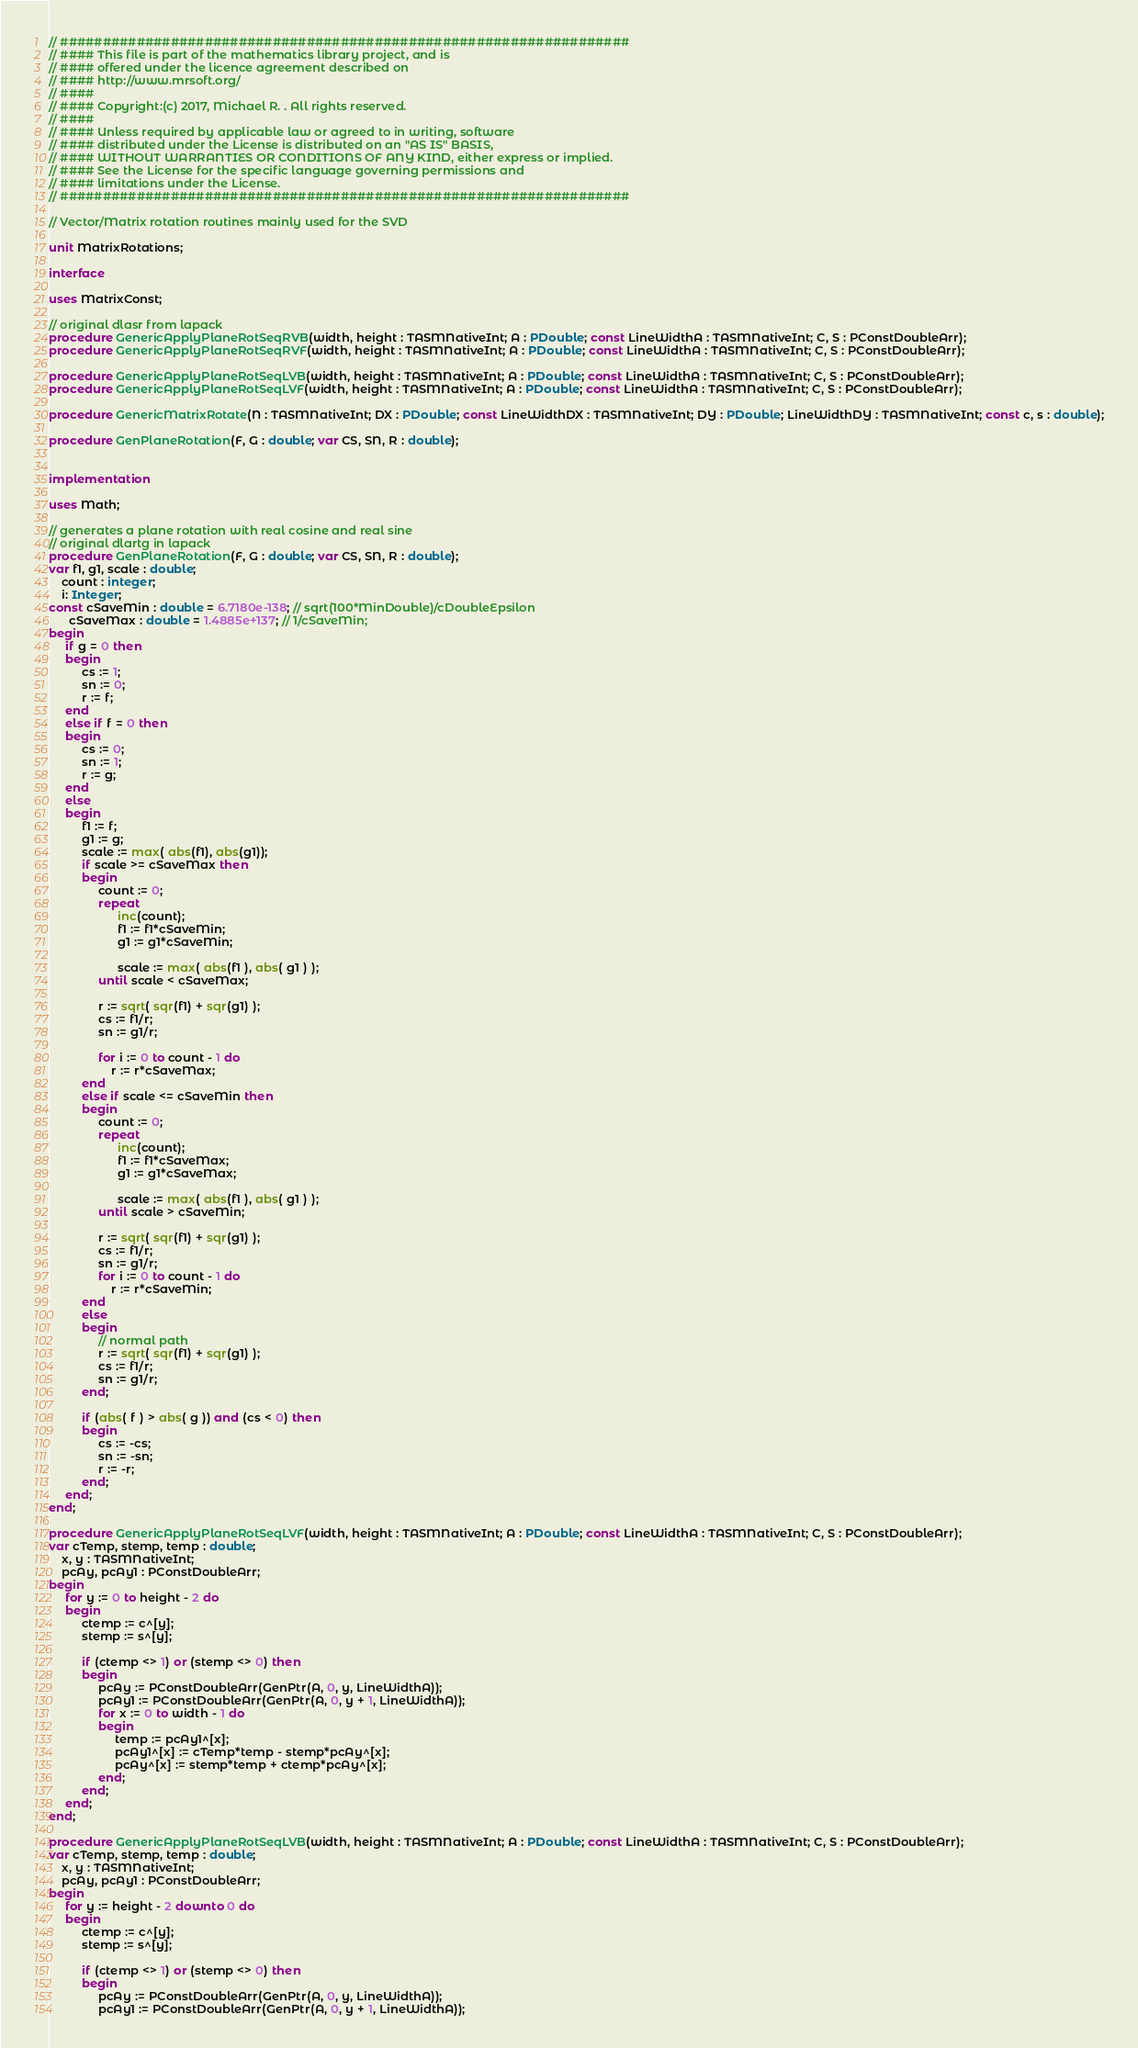<code> <loc_0><loc_0><loc_500><loc_500><_Pascal_>// ###################################################################
// #### This file is part of the mathematics library project, and is
// #### offered under the licence agreement described on
// #### http://www.mrsoft.org/
// ####
// #### Copyright:(c) 2017, Michael R. . All rights reserved.
// ####
// #### Unless required by applicable law or agreed to in writing, software
// #### distributed under the License is distributed on an "AS IS" BASIS,
// #### WITHOUT WARRANTIES OR CONDITIONS OF ANY KIND, either express or implied.
// #### See the License for the specific language governing permissions and
// #### limitations under the License.
// ###################################################################

// Vector/Matrix rotation routines mainly used for the SVD

unit MatrixRotations;

interface

uses MatrixConst;

// original dlasr from lapack
procedure GenericApplyPlaneRotSeqRVB(width, height : TASMNativeInt; A : PDouble; const LineWidthA : TASMNativeInt; C, S : PConstDoubleArr);
procedure GenericApplyPlaneRotSeqRVF(width, height : TASMNativeInt; A : PDouble; const LineWidthA : TASMNativeInt; C, S : PConstDoubleArr);

procedure GenericApplyPlaneRotSeqLVB(width, height : TASMNativeInt; A : PDouble; const LineWidthA : TASMNativeInt; C, S : PConstDoubleArr);
procedure GenericApplyPlaneRotSeqLVF(width, height : TASMNativeInt; A : PDouble; const LineWidthA : TASMNativeInt; C, S : PConstDoubleArr);

procedure GenericMatrixRotate(N : TASMNativeInt; DX : PDouble; const LineWidthDX : TASMNativeInt; DY : PDouble; LineWidthDY : TASMNativeInt; const c, s : double);

procedure GenPlaneRotation(F, G : double; var CS, SN, R : double);


implementation

uses Math;

// generates a plane rotation with real cosine and real sine
// original dlartg in lapack
procedure GenPlaneRotation(F, G : double; var CS, SN, R : double);
var f1, g1, scale : double;
    count : integer;
    i: Integer;
const cSaveMin : double = 6.7180e-138; // sqrt(100*MinDouble)/cDoubleEpsilon
      cSaveMax : double = 1.4885e+137; // 1/cSaveMin;
begin
     if g = 0 then
     begin
          cs := 1;
          sn := 0;
          r := f;
     end
     else if f = 0 then
     begin
          cs := 0;
          sn := 1;
          r := g;
     end
     else
     begin
          f1 := f;
          g1 := g;
          scale := max( abs(f1), abs(g1));
          if scale >= cSaveMax then
          begin
               count := 0;
               repeat
                     inc(count);
                     f1 := f1*cSaveMin;
                     g1 := g1*cSaveMin;

                     scale := max( abs(f1 ), abs( g1 ) );
               until scale < cSaveMax;

               r := sqrt( sqr(f1) + sqr(g1) );
               cs := f1/r;
               sn := g1/r;

               for i := 0 to count - 1 do
                   r := r*cSaveMax;
          end
          else if scale <= cSaveMin then
          begin
               count := 0;
               repeat
                     inc(count);
                     f1 := f1*cSaveMax;
                     g1 := g1*cSaveMax;

                     scale := max( abs(f1 ), abs( g1 ) );
               until scale > cSaveMin;

               r := sqrt( sqr(f1) + sqr(g1) );
               cs := f1/r;
               sn := g1/r;
               for i := 0 to count - 1 do
                   r := r*cSaveMin;
          end
          else
          begin
               // normal path
               r := sqrt( sqr(f1) + sqr(g1) );
               cs := f1/r;
               sn := g1/r;
          end;

          if (abs( f ) > abs( g )) and (cs < 0) then
          begin
               cs := -cs;
               sn := -sn;
               r := -r;
          end;
     end;
end;

procedure GenericApplyPlaneRotSeqLVF(width, height : TASMNativeInt; A : PDouble; const LineWidthA : TASMNativeInt; C, S : PConstDoubleArr);
var cTemp, stemp, temp : double;
    x, y : TASMNativeInt;
    pcAy, pcAy1 : PConstDoubleArr;
begin
     for y := 0 to height - 2 do
     begin
          ctemp := c^[y];
          stemp := s^[y];

          if (ctemp <> 1) or (stemp <> 0) then
          begin
               pcAy := PConstDoubleArr(GenPtr(A, 0, y, LineWidthA));
               pcAy1 := PConstDoubleArr(GenPtr(A, 0, y + 1, LineWidthA));
               for x := 0 to width - 1 do
               begin
                    temp := pcAy1^[x];
                    pcAy1^[x] := cTemp*temp - stemp*pcAy^[x];
                    pcAy^[x] := stemp*temp + ctemp*pcAy^[x];
               end;
          end;
     end;
end;

procedure GenericApplyPlaneRotSeqLVB(width, height : TASMNativeInt; A : PDouble; const LineWidthA : TASMNativeInt; C, S : PConstDoubleArr);
var cTemp, stemp, temp : double;
    x, y : TASMNativeInt;
    pcAy, pcAy1 : PConstDoubleArr;
begin
     for y := height - 2 downto 0 do
     begin
          ctemp := c^[y];
          stemp := s^[y];

          if (ctemp <> 1) or (stemp <> 0) then
          begin
               pcAy := PConstDoubleArr(GenPtr(A, 0, y, LineWidthA));
               pcAy1 := PConstDoubleArr(GenPtr(A, 0, y + 1, LineWidthA));</code> 